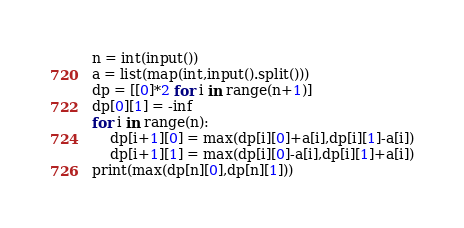Convert code to text. <code><loc_0><loc_0><loc_500><loc_500><_Python_>n = int(input())
a = list(map(int,input().split()))
dp = [[0]*2 for i in range(n+1)]
dp[0][1] = -inf
for i in range(n):
    dp[i+1][0] = max(dp[i][0]+a[i],dp[i][1]-a[i])
    dp[i+1][1] = max(dp[i][0]-a[i],dp[i][1]+a[i])
print(max(dp[n][0],dp[n][1]))</code> 